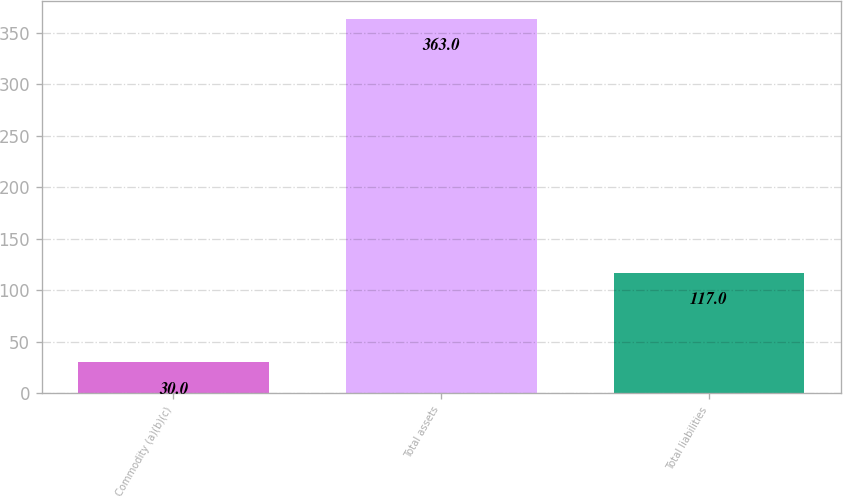Convert chart. <chart><loc_0><loc_0><loc_500><loc_500><bar_chart><fcel>Commodity (a)(b)(c)<fcel>Total assets<fcel>Total liabilities<nl><fcel>30<fcel>363<fcel>117<nl></chart> 